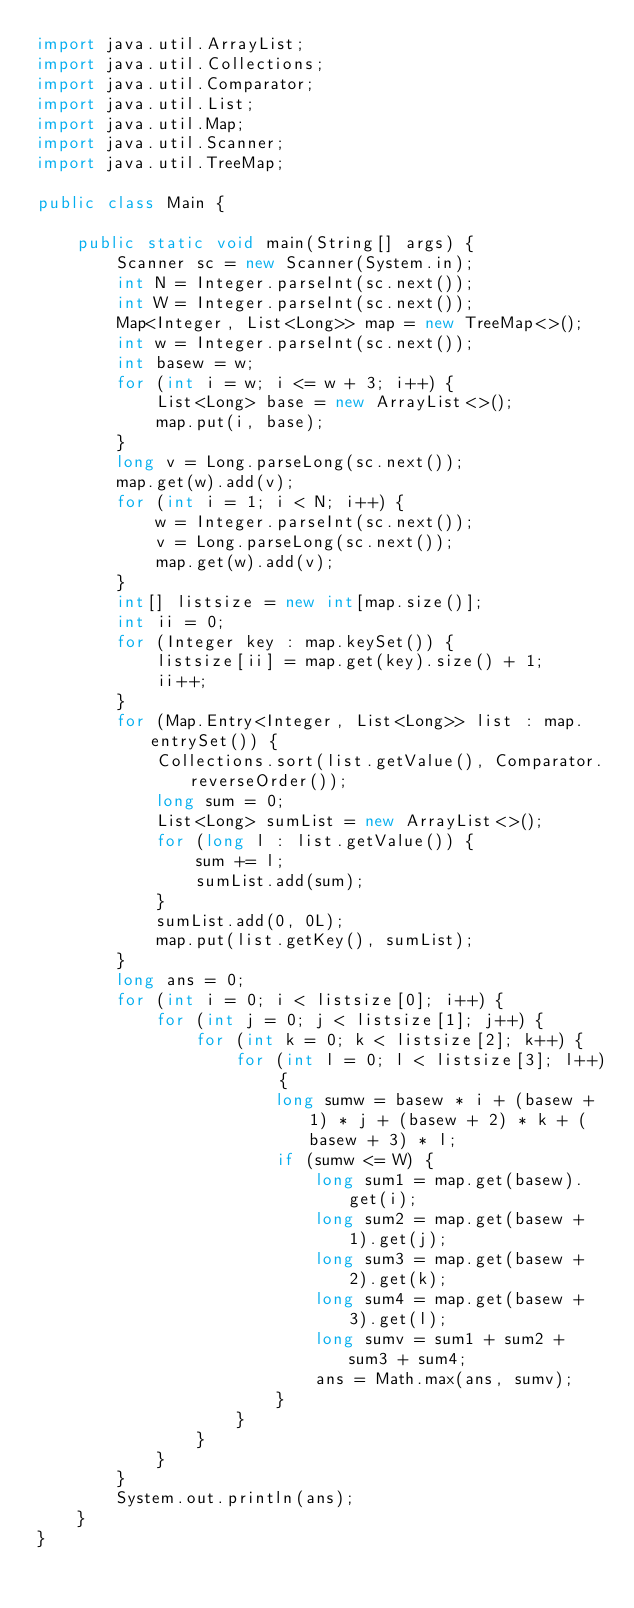Convert code to text. <code><loc_0><loc_0><loc_500><loc_500><_Java_>import java.util.ArrayList;
import java.util.Collections;
import java.util.Comparator;
import java.util.List;
import java.util.Map;
import java.util.Scanner;
import java.util.TreeMap;

public class Main {

    public static void main(String[] args) {
        Scanner sc = new Scanner(System.in);
        int N = Integer.parseInt(sc.next());
        int W = Integer.parseInt(sc.next());
        Map<Integer, List<Long>> map = new TreeMap<>();
        int w = Integer.parseInt(sc.next());
        int basew = w;
        for (int i = w; i <= w + 3; i++) {
            List<Long> base = new ArrayList<>();
            map.put(i, base);
        }
        long v = Long.parseLong(sc.next());
        map.get(w).add(v);
        for (int i = 1; i < N; i++) {
            w = Integer.parseInt(sc.next());
            v = Long.parseLong(sc.next());
            map.get(w).add(v);
        }
        int[] listsize = new int[map.size()];
        int ii = 0;
        for (Integer key : map.keySet()) {
            listsize[ii] = map.get(key).size() + 1;
            ii++;
        }
        for (Map.Entry<Integer, List<Long>> list : map.entrySet()) {
            Collections.sort(list.getValue(), Comparator.reverseOrder());
            long sum = 0;
            List<Long> sumList = new ArrayList<>();
            for (long l : list.getValue()) {
                sum += l;
                sumList.add(sum);
            }
            sumList.add(0, 0L);
            map.put(list.getKey(), sumList);
        }
        long ans = 0;
        for (int i = 0; i < listsize[0]; i++) {
            for (int j = 0; j < listsize[1]; j++) {
                for (int k = 0; k < listsize[2]; k++) {
                    for (int l = 0; l < listsize[3]; l++) {
                        long sumw = basew * i + (basew + 1) * j + (basew + 2) * k + (basew + 3) * l;
                        if (sumw <= W) {
                            long sum1 = map.get(basew).get(i);
                            long sum2 = map.get(basew + 1).get(j);
                            long sum3 = map.get(basew + 2).get(k);
                            long sum4 = map.get(basew + 3).get(l);
                            long sumv = sum1 + sum2 + sum3 + sum4;
                            ans = Math.max(ans, sumv);
                        }
                    }
                }
            }
        }
        System.out.println(ans);
    }
}</code> 